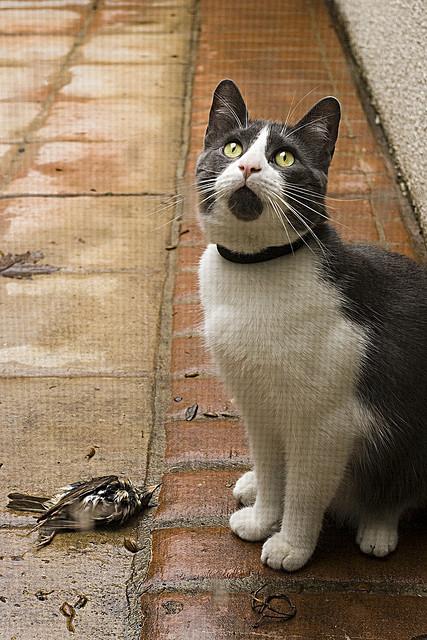Is this outside?
Give a very brief answer. Yes. Did the cat kill the bird?
Write a very short answer. Yes. Is the cat sleeping?
Give a very brief answer. No. 